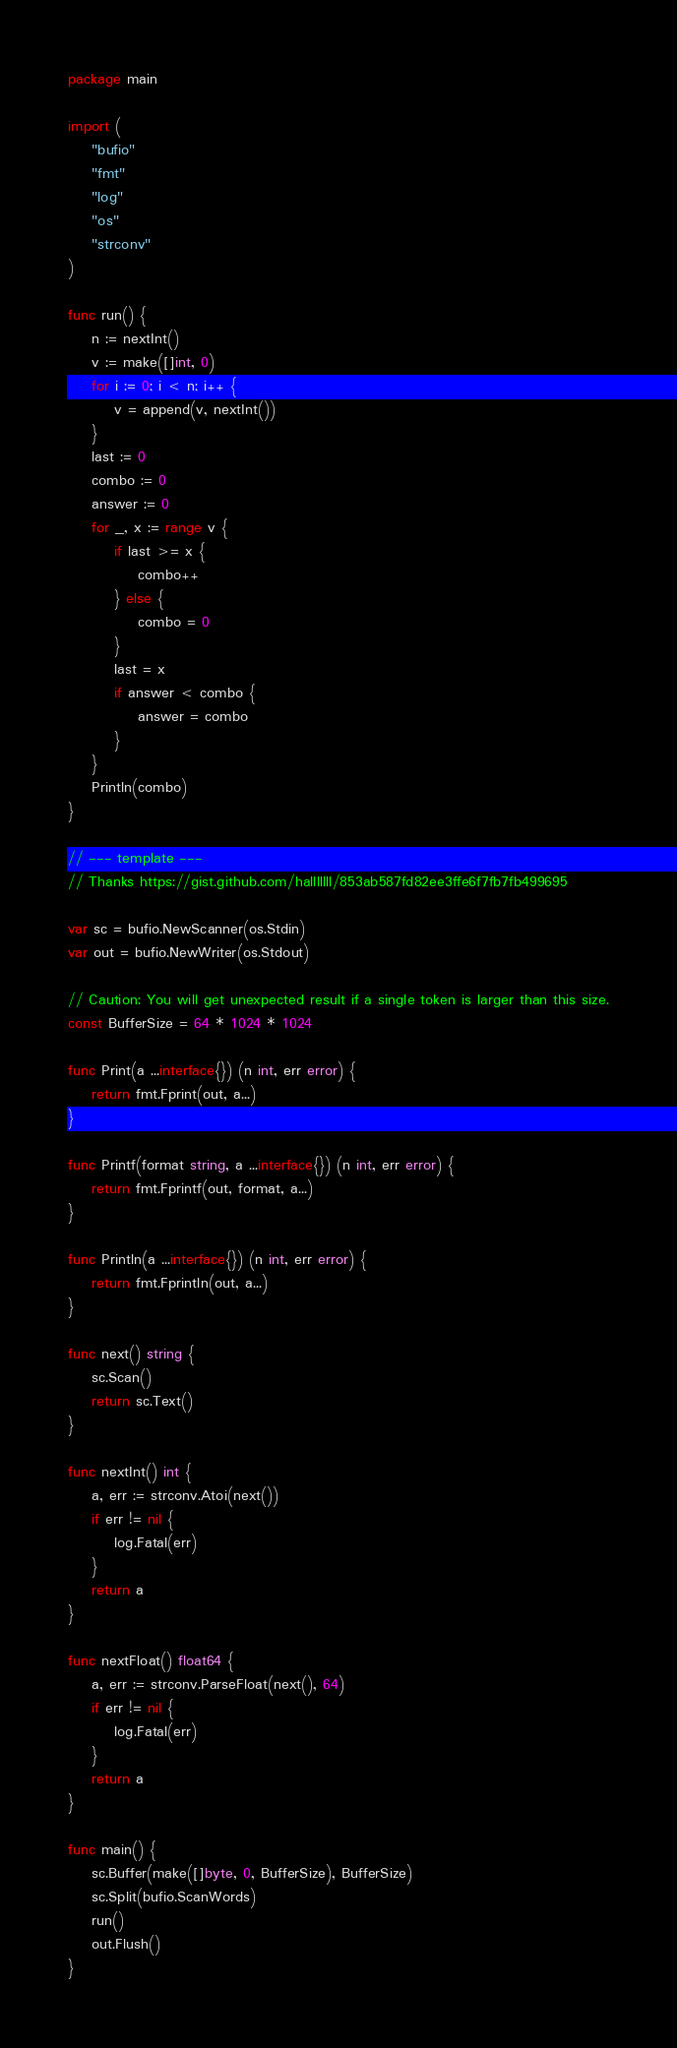<code> <loc_0><loc_0><loc_500><loc_500><_Go_>package main

import (
	"bufio"
	"fmt"
	"log"
	"os"
	"strconv"
)

func run() {
	n := nextInt()
	v := make([]int, 0)
	for i := 0; i < n; i++ {
		v = append(v, nextInt())
	}
	last := 0
	combo := 0
	answer := 0
	for _, x := range v {
		if last >= x {
			combo++
		} else {
			combo = 0
		}
		last = x
		if answer < combo {
			answer = combo
		}
	}
	Println(combo)
}

// --- template ---
// Thanks https://gist.github.com/halllllll/853ab587fd82ee3ffe6f7fb7fb499695

var sc = bufio.NewScanner(os.Stdin)
var out = bufio.NewWriter(os.Stdout)

// Caution: You will get unexpected result if a single token is larger than this size.
const BufferSize = 64 * 1024 * 1024

func Print(a ...interface{}) (n int, err error) {
	return fmt.Fprint(out, a...)
}

func Printf(format string, a ...interface{}) (n int, err error) {
	return fmt.Fprintf(out, format, a...)
}

func Println(a ...interface{}) (n int, err error) {
	return fmt.Fprintln(out, a...)
}

func next() string {
	sc.Scan()
	return sc.Text()
}

func nextInt() int {
	a, err := strconv.Atoi(next())
	if err != nil {
		log.Fatal(err)
	}
	return a
}

func nextFloat() float64 {
	a, err := strconv.ParseFloat(next(), 64)
	if err != nil {
		log.Fatal(err)
	}
	return a
}

func main() {
	sc.Buffer(make([]byte, 0, BufferSize), BufferSize)
	sc.Split(bufio.ScanWords)
	run()
	out.Flush()
}
</code> 